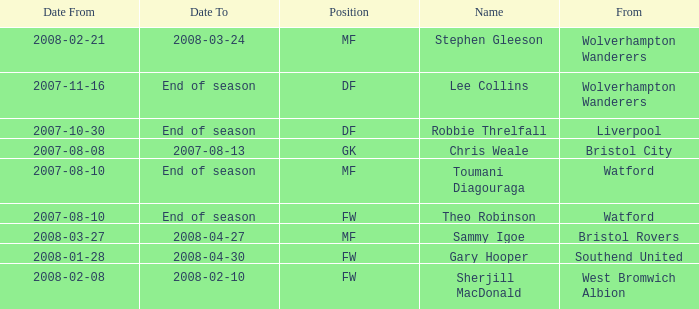What date did Toumani Diagouraga, who played position MF, start? 2007-08-10. 